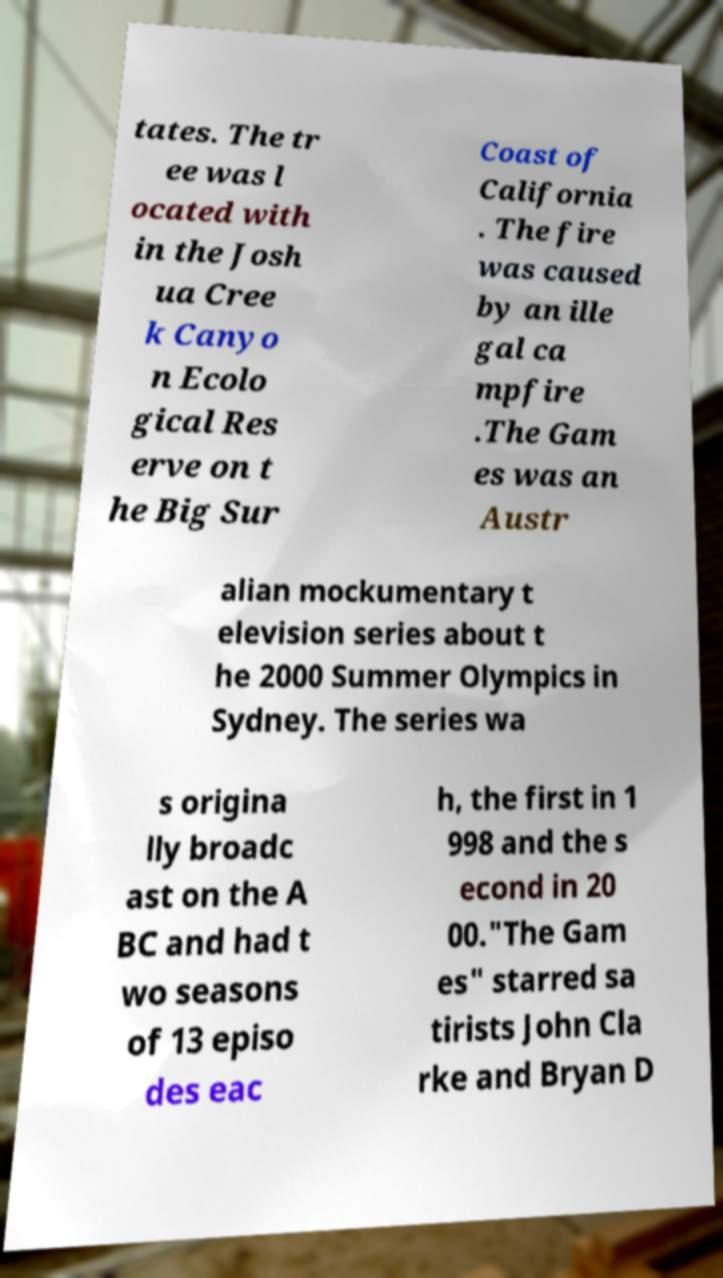Can you read and provide the text displayed in the image?This photo seems to have some interesting text. Can you extract and type it out for me? tates. The tr ee was l ocated with in the Josh ua Cree k Canyo n Ecolo gical Res erve on t he Big Sur Coast of California . The fire was caused by an ille gal ca mpfire .The Gam es was an Austr alian mockumentary t elevision series about t he 2000 Summer Olympics in Sydney. The series wa s origina lly broadc ast on the A BC and had t wo seasons of 13 episo des eac h, the first in 1 998 and the s econd in 20 00."The Gam es" starred sa tirists John Cla rke and Bryan D 